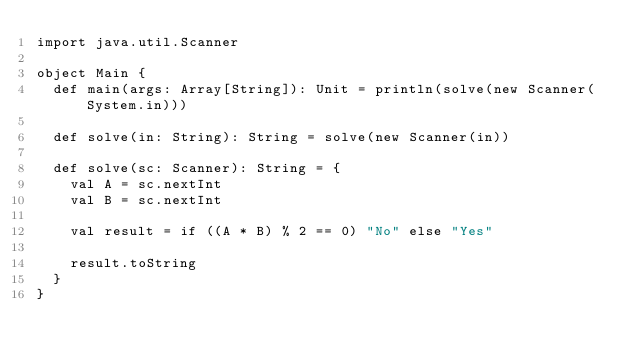Convert code to text. <code><loc_0><loc_0><loc_500><loc_500><_Scala_>import java.util.Scanner

object Main {
  def main(args: Array[String]): Unit = println(solve(new Scanner(System.in)))

  def solve(in: String): String = solve(new Scanner(in))

  def solve(sc: Scanner): String = {
    val A = sc.nextInt
    val B = sc.nextInt

    val result = if ((A * B) % 2 == 0) "No" else "Yes"

    result.toString
  }
}
</code> 